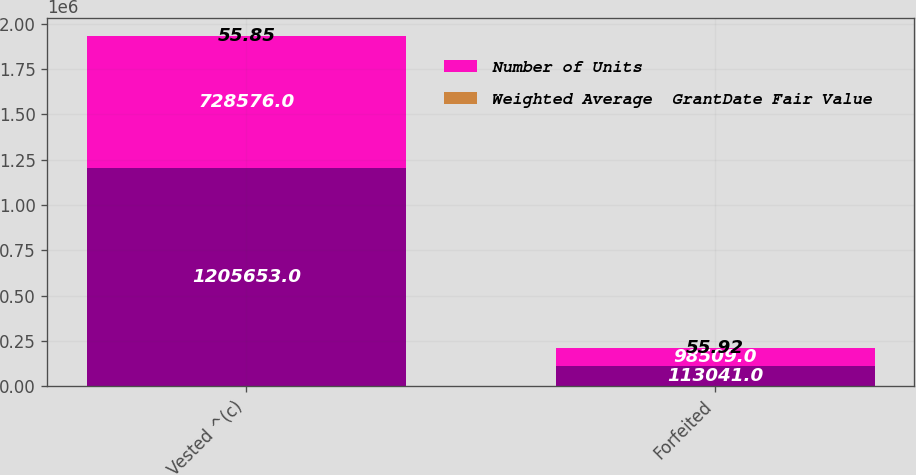Convert chart to OTSL. <chart><loc_0><loc_0><loc_500><loc_500><stacked_bar_chart><ecel><fcel>Vested ^(c)<fcel>Forfeited<nl><fcel>nan<fcel>1.20565e+06<fcel>113041<nl><fcel>Number of Units<fcel>728576<fcel>98509<nl><fcel>Weighted Average  GrantDate Fair Value<fcel>55.85<fcel>55.92<nl></chart> 